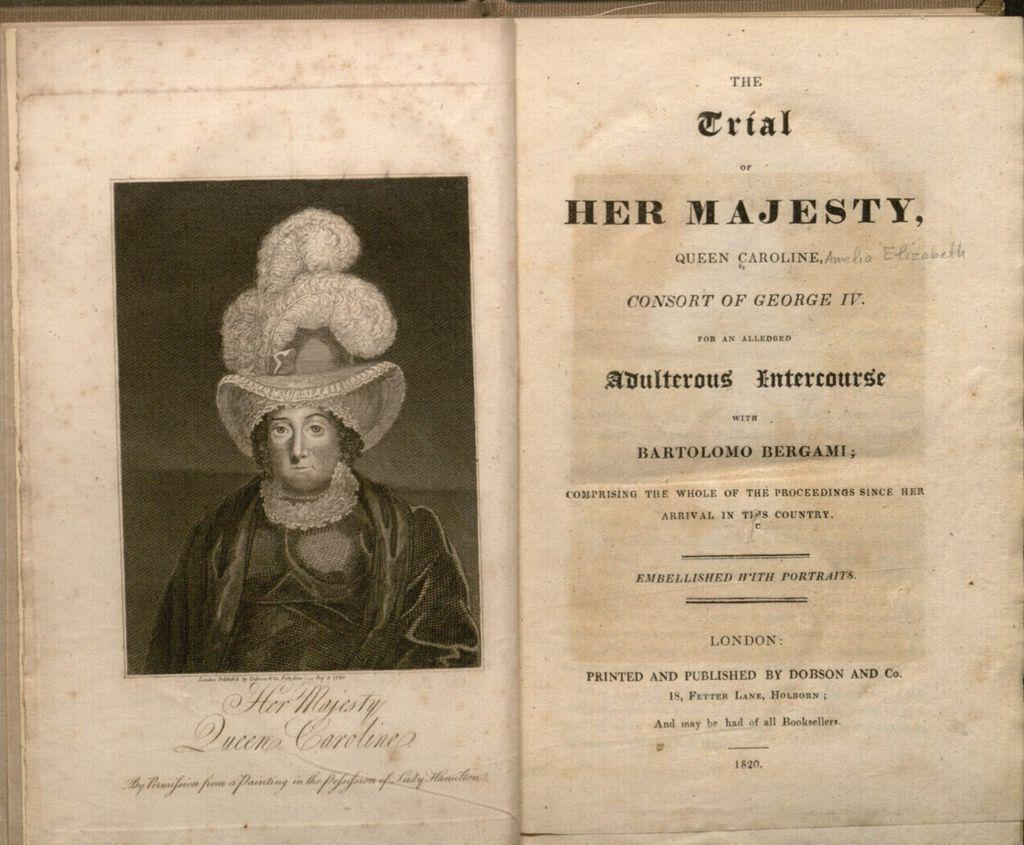What is the main object in the image? There is a book in the image. What can be seen in the photo inside the book? The photo in the book contains a person. What type of content is present on the pages of the book? There are words and numbers on the pages of the book. Can you tell me how many pickles are mentioned in the book? There is no mention of pickles in the book; it contains a photo of a person and words and numbers on the pages. Is there a pig visible in the photo inside the book? There is no pig visible in the photo inside the book; it contains a photo of a person. 